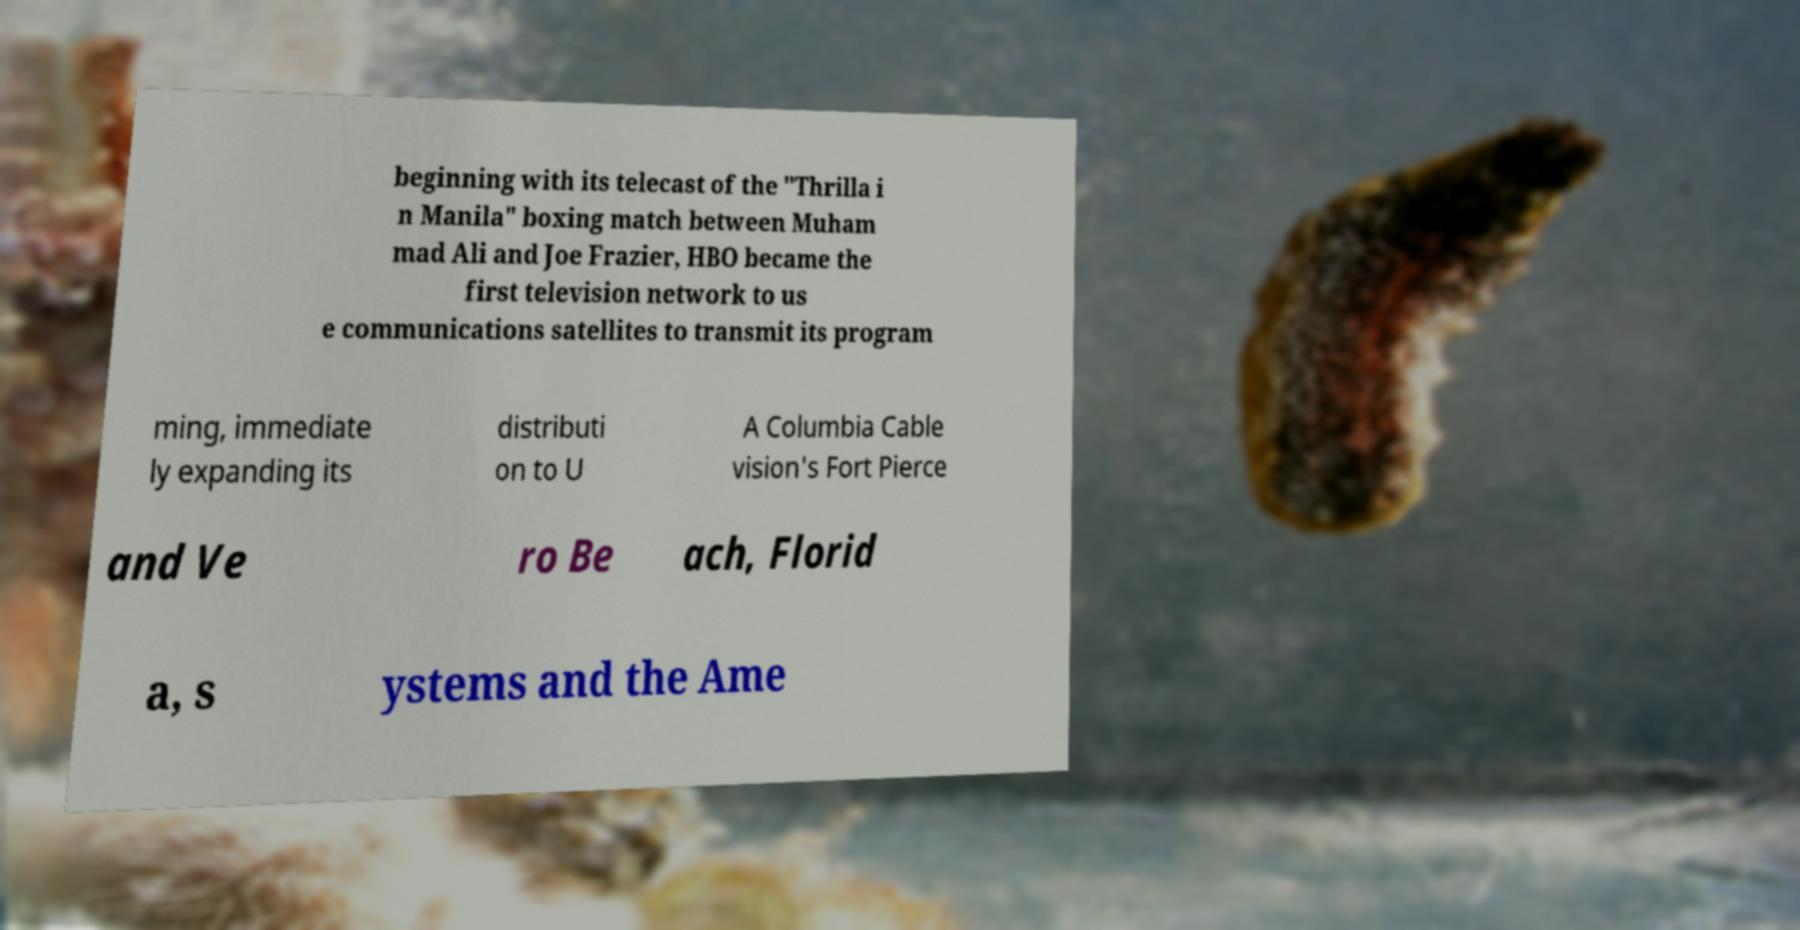What messages or text are displayed in this image? I need them in a readable, typed format. beginning with its telecast of the "Thrilla i n Manila" boxing match between Muham mad Ali and Joe Frazier, HBO became the first television network to us e communications satellites to transmit its program ming, immediate ly expanding its distributi on to U A Columbia Cable vision's Fort Pierce and Ve ro Be ach, Florid a, s ystems and the Ame 